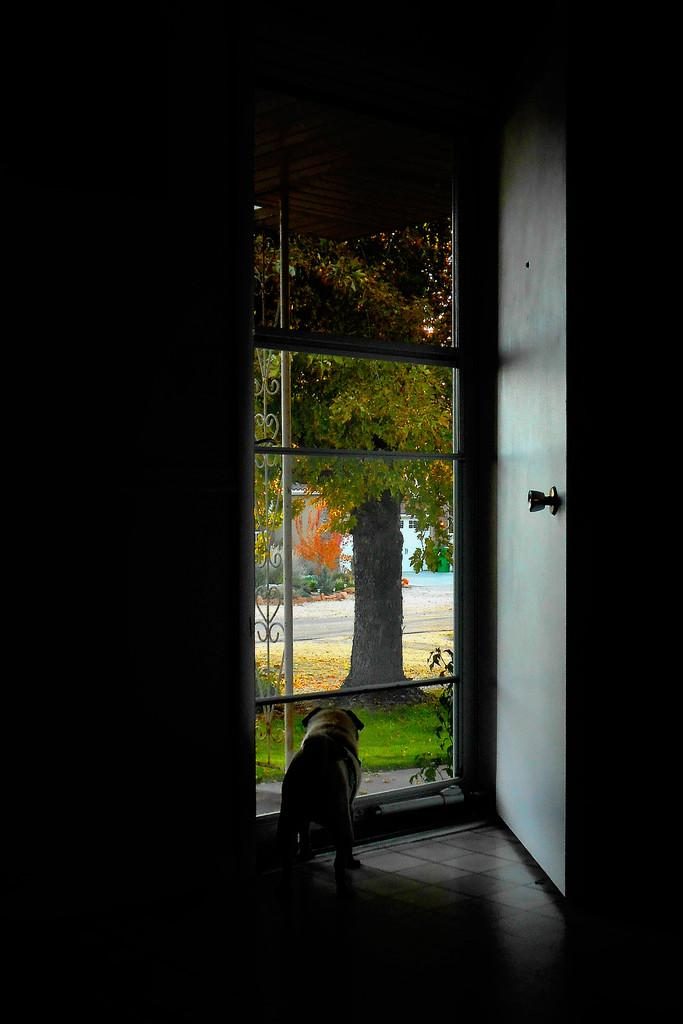What type of animal is on the floor in the image? There is a dog on the floor in the image. Where is the dog located in relation to the door? The dog is beside a door in the image. What type of outdoor environment can be seen in the image? There is grass, a tree, and plants visible in the image. What structures are present in the image? There are poles in the image. What type of prose is being recited by the dog in the image? There is no indication in the image that the dog is reciting any prose. What design elements can be seen in the park in the image? There is no park present in the image; it features a dog, a door, grass, a tree, plants, and poles. 